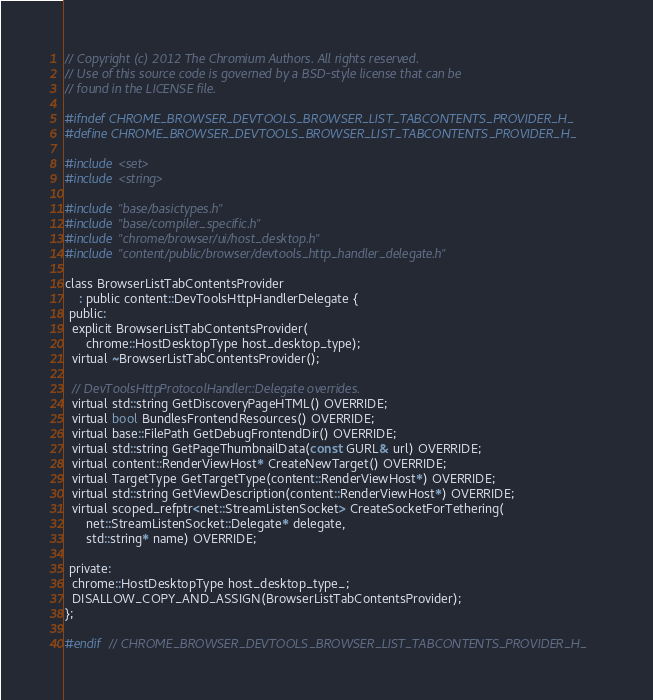<code> <loc_0><loc_0><loc_500><loc_500><_C_>// Copyright (c) 2012 The Chromium Authors. All rights reserved.
// Use of this source code is governed by a BSD-style license that can be
// found in the LICENSE file.

#ifndef CHROME_BROWSER_DEVTOOLS_BROWSER_LIST_TABCONTENTS_PROVIDER_H_
#define CHROME_BROWSER_DEVTOOLS_BROWSER_LIST_TABCONTENTS_PROVIDER_H_

#include <set>
#include <string>

#include "base/basictypes.h"
#include "base/compiler_specific.h"
#include "chrome/browser/ui/host_desktop.h"
#include "content/public/browser/devtools_http_handler_delegate.h"

class BrowserListTabContentsProvider
    : public content::DevToolsHttpHandlerDelegate {
 public:
  explicit BrowserListTabContentsProvider(
      chrome::HostDesktopType host_desktop_type);
  virtual ~BrowserListTabContentsProvider();

  // DevToolsHttpProtocolHandler::Delegate overrides.
  virtual std::string GetDiscoveryPageHTML() OVERRIDE;
  virtual bool BundlesFrontendResources() OVERRIDE;
  virtual base::FilePath GetDebugFrontendDir() OVERRIDE;
  virtual std::string GetPageThumbnailData(const GURL& url) OVERRIDE;
  virtual content::RenderViewHost* CreateNewTarget() OVERRIDE;
  virtual TargetType GetTargetType(content::RenderViewHost*) OVERRIDE;
  virtual std::string GetViewDescription(content::RenderViewHost*) OVERRIDE;
  virtual scoped_refptr<net::StreamListenSocket> CreateSocketForTethering(
      net::StreamListenSocket::Delegate* delegate,
      std::string* name) OVERRIDE;

 private:
  chrome::HostDesktopType host_desktop_type_;
  DISALLOW_COPY_AND_ASSIGN(BrowserListTabContentsProvider);
};

#endif  // CHROME_BROWSER_DEVTOOLS_BROWSER_LIST_TABCONTENTS_PROVIDER_H_
</code> 